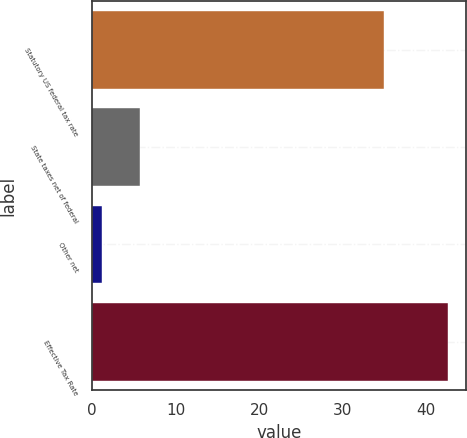<chart> <loc_0><loc_0><loc_500><loc_500><bar_chart><fcel>Statutory US federal tax rate<fcel>State taxes net of federal<fcel>Other net<fcel>Effective Tax Rate<nl><fcel>35<fcel>5.7<fcel>1.2<fcel>42.7<nl></chart> 